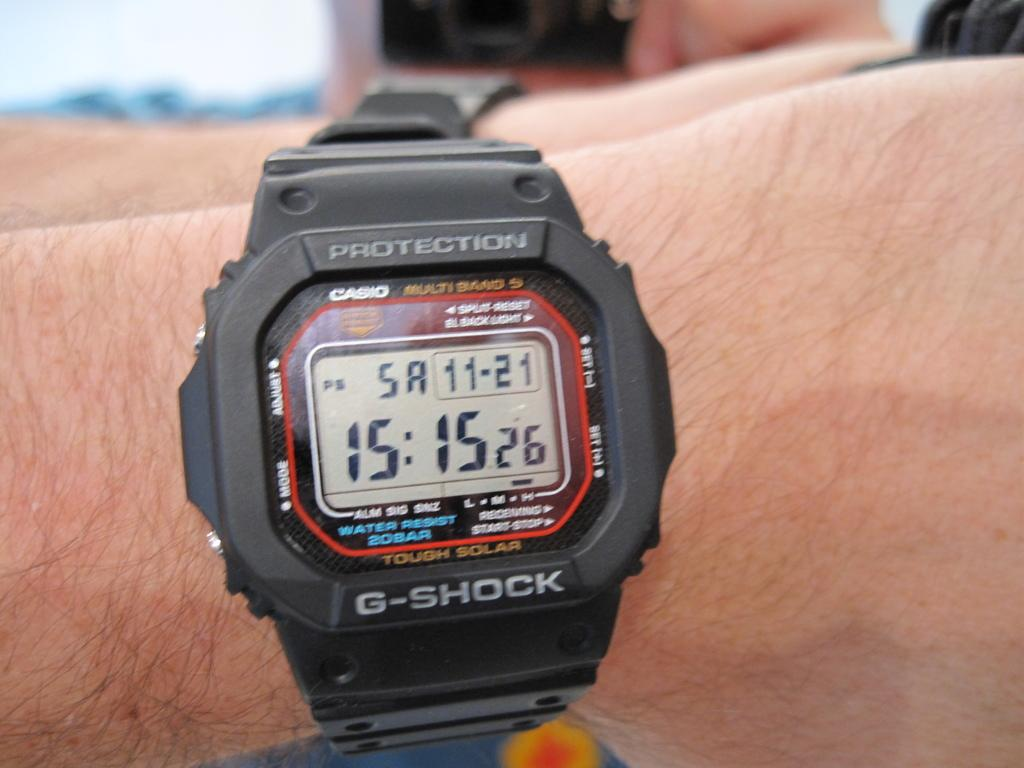<image>
Share a concise interpretation of the image provided. A Protection G-Shock watch has the time of 15:15. 